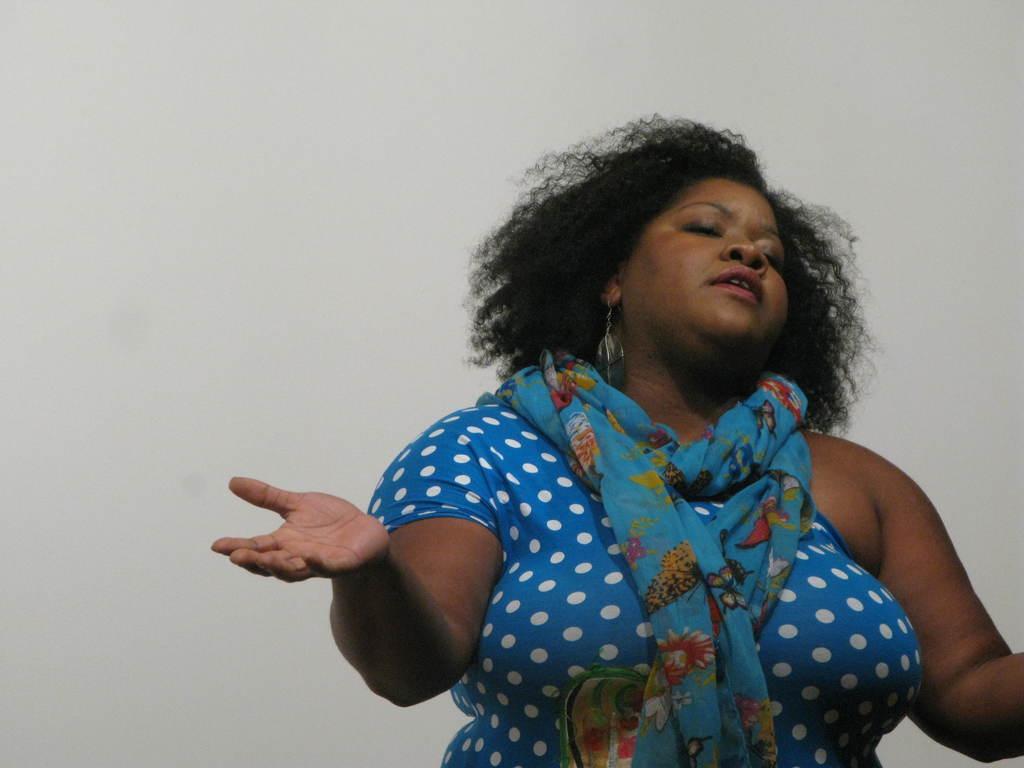In one or two sentences, can you explain what this image depicts? In this image, we can see a person wearing clothes and scarf. 